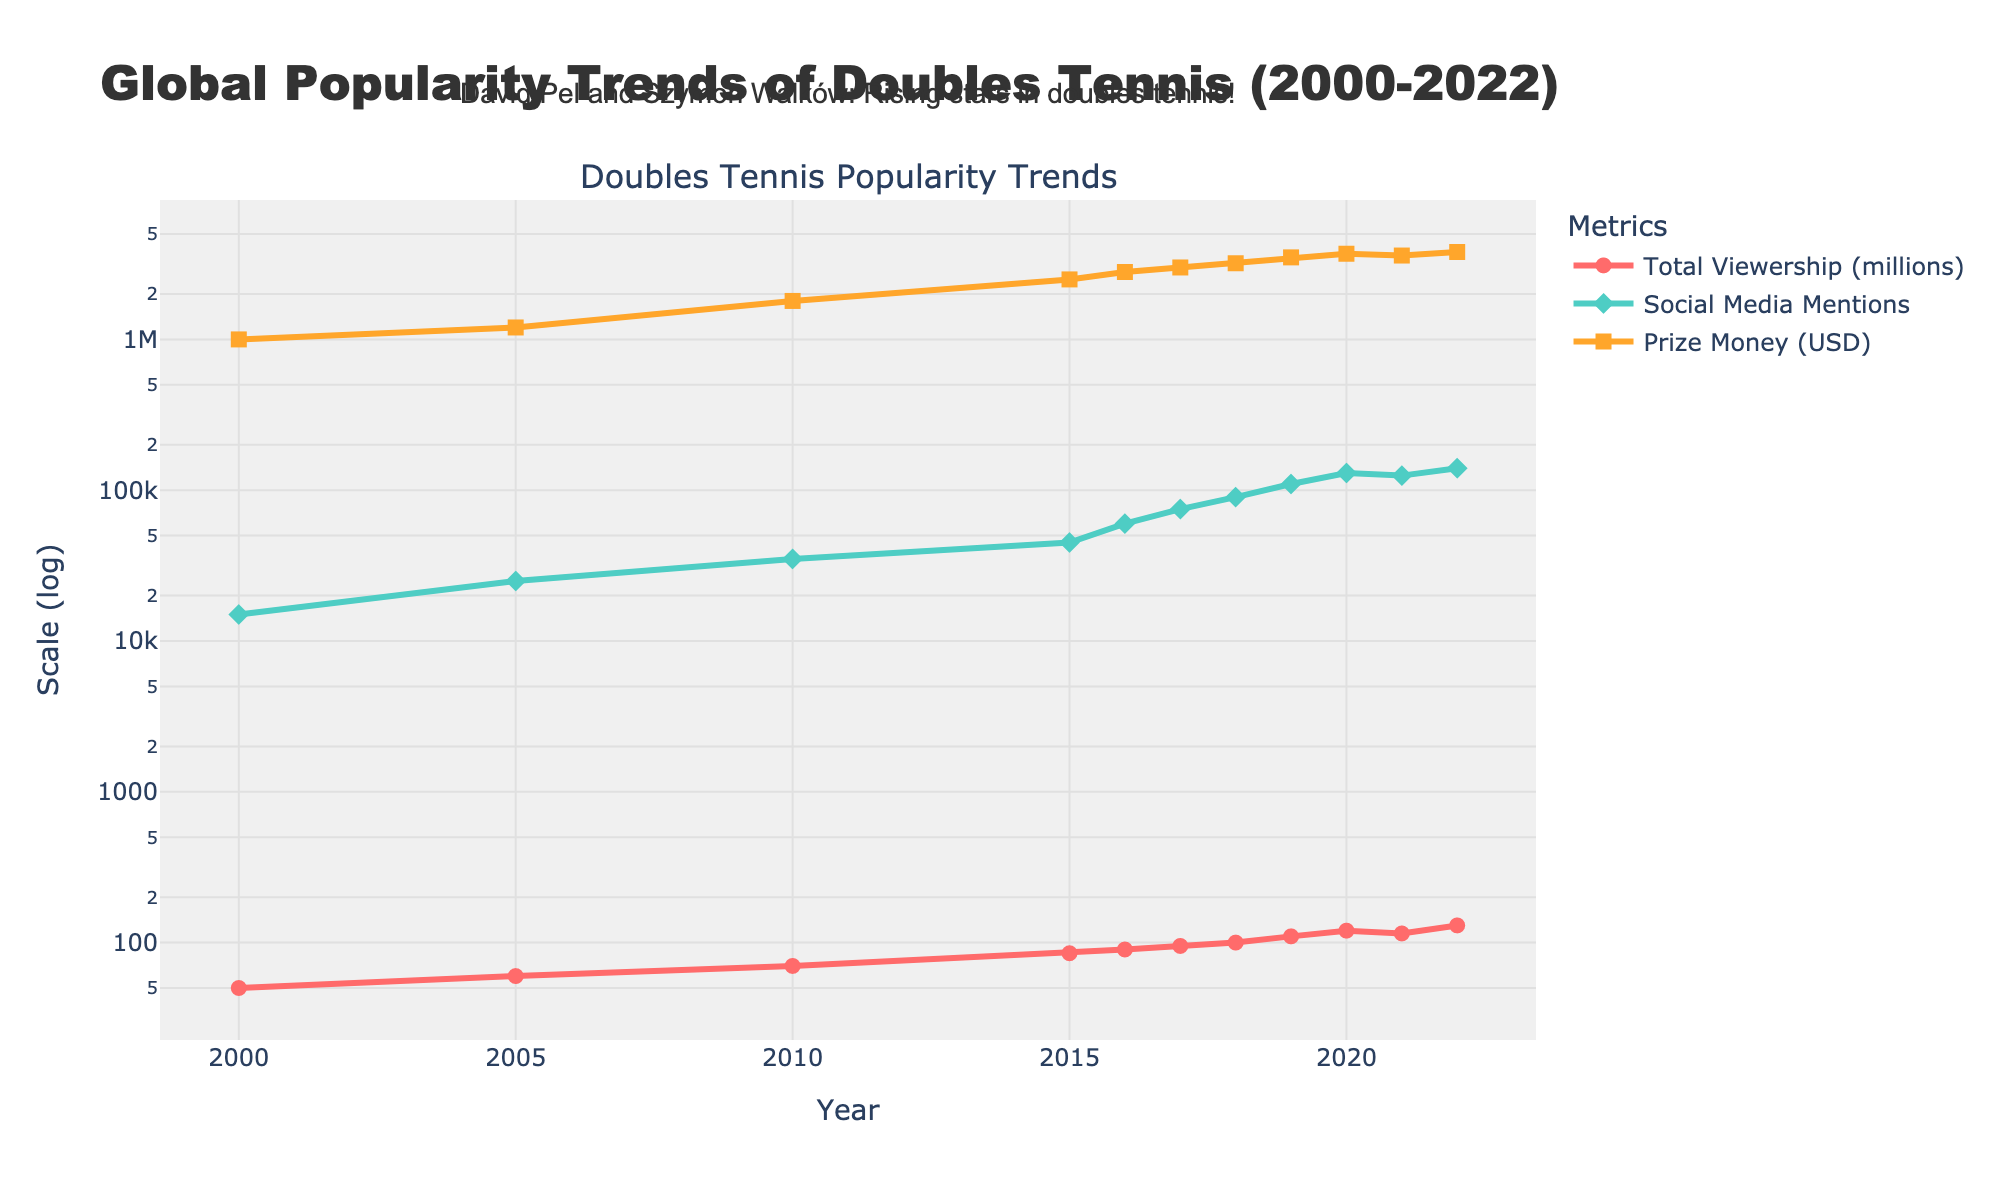What is the title of the figure? The title is usually displayed at the top of the figure. It helps to provide an overview of what the figure represents.
Answer: Global Popularity Trends of Doubles Tennis (2000-2022) How many Grand Slam events are included in each year in the figure? Look for a dataset or axis label indicating the number of Grand Slam events. The data for each year shows that the number remains constant over time.
Answer: 4 What trend can be observed in overall prize money from 2000 to 2022? Trace the line plot for 'Prize Money (USD)' from left to right and observe the general direction or pattern it follows. The prize money shows a steady increase over the years.
Answer: It increases In which year did 'Social Media Mentions' first surpass 100,000? Follow the line plot for 'Social Media Mentions' and look for the first point where it exceeds 100,000 mentions.
Answer: 2019 Which year had the highest total viewership? Check the highest point on the line plot representing 'Total Viewership (millions)'.
Answer: 2022 Compare the increase in 'Total Viewership (millions)' and 'Prize Money (USD)' from 2005 to 2010. Which one increased more? Calculate the increase for both metrics from 2005 to 2010. 
Total Viewership: 70 - 60 = 10 million; 
Prize Money: 1800000 - 1200000 = 600000. 
Then compare the increases.
Answer: Prize Money (USD) What was the average social media mentions between 2015 and 2020? Add the 'Social Media Mentions' values from 2015 to 2020 and divide by the number of years. 
(45000 + 60000 + 75000 + 90000 + 110000 + 130000) / 6 = 85000.
Answer: 85,000 How does the use of a log scale on the y-axis affect the interpretation of trends in the data? A log scale means exponential growth appears as linear growth, making it easier to visualize wide-ranging data. For example, small variations might seem larger and major trends more noticeable.
Answer: It helps visualize exponential growth Identify the steepest increase in 'Social Media Mentions' between two consecutive years. Which years were they? Look for the sharpest incline in the 'Social Media Mentions' line plot and note the corresponding years. From 2015 to 2016, Mentions increased from 45000 to 60000, which is steep but not the steepest. The steepest is from 2018 to 2019, from 90000 to 110000.
Answer: 2018 to 2019 Based on the figure, was there any year where 'Total Viewership (millions)' decreased from the previous year? Check for any points in the 'Total Viewership (millions)' line plot where the value at a specific year is lower than the preceding year.
Answer: 2021 